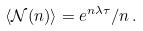<formula> <loc_0><loc_0><loc_500><loc_500>\langle \mathcal { N } ( n ) \rangle = e ^ { n \lambda \tau } / n \, .</formula> 